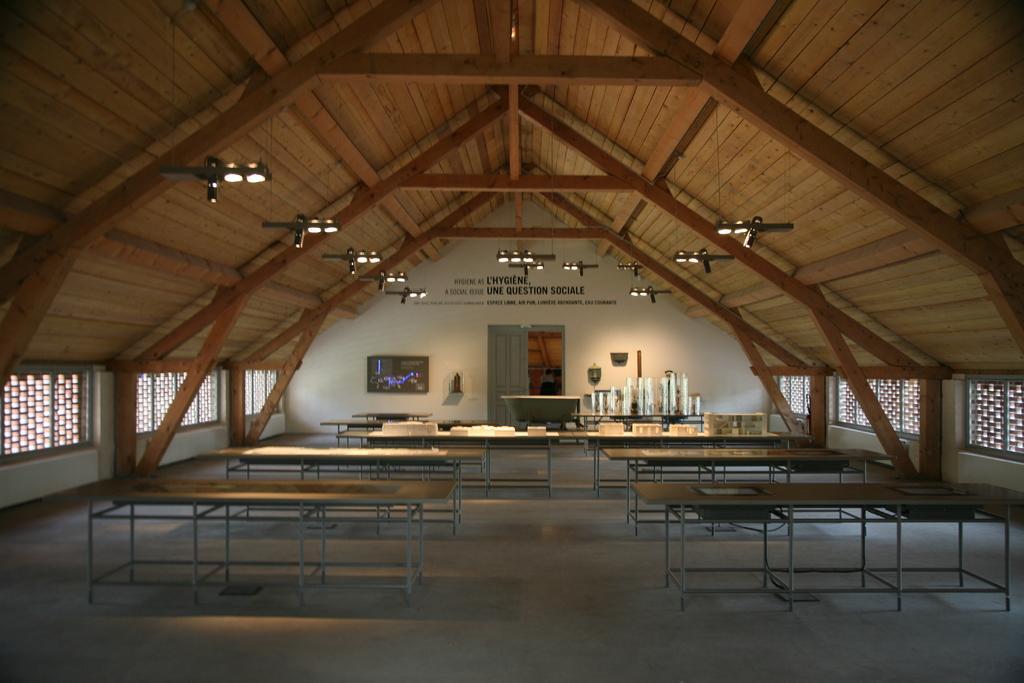In one or two sentences, can you explain what this image depicts? This image consists of tables in the middle. On that there are plates, glasses in the middle. There is a door in the middle. There are lights in the middle. 